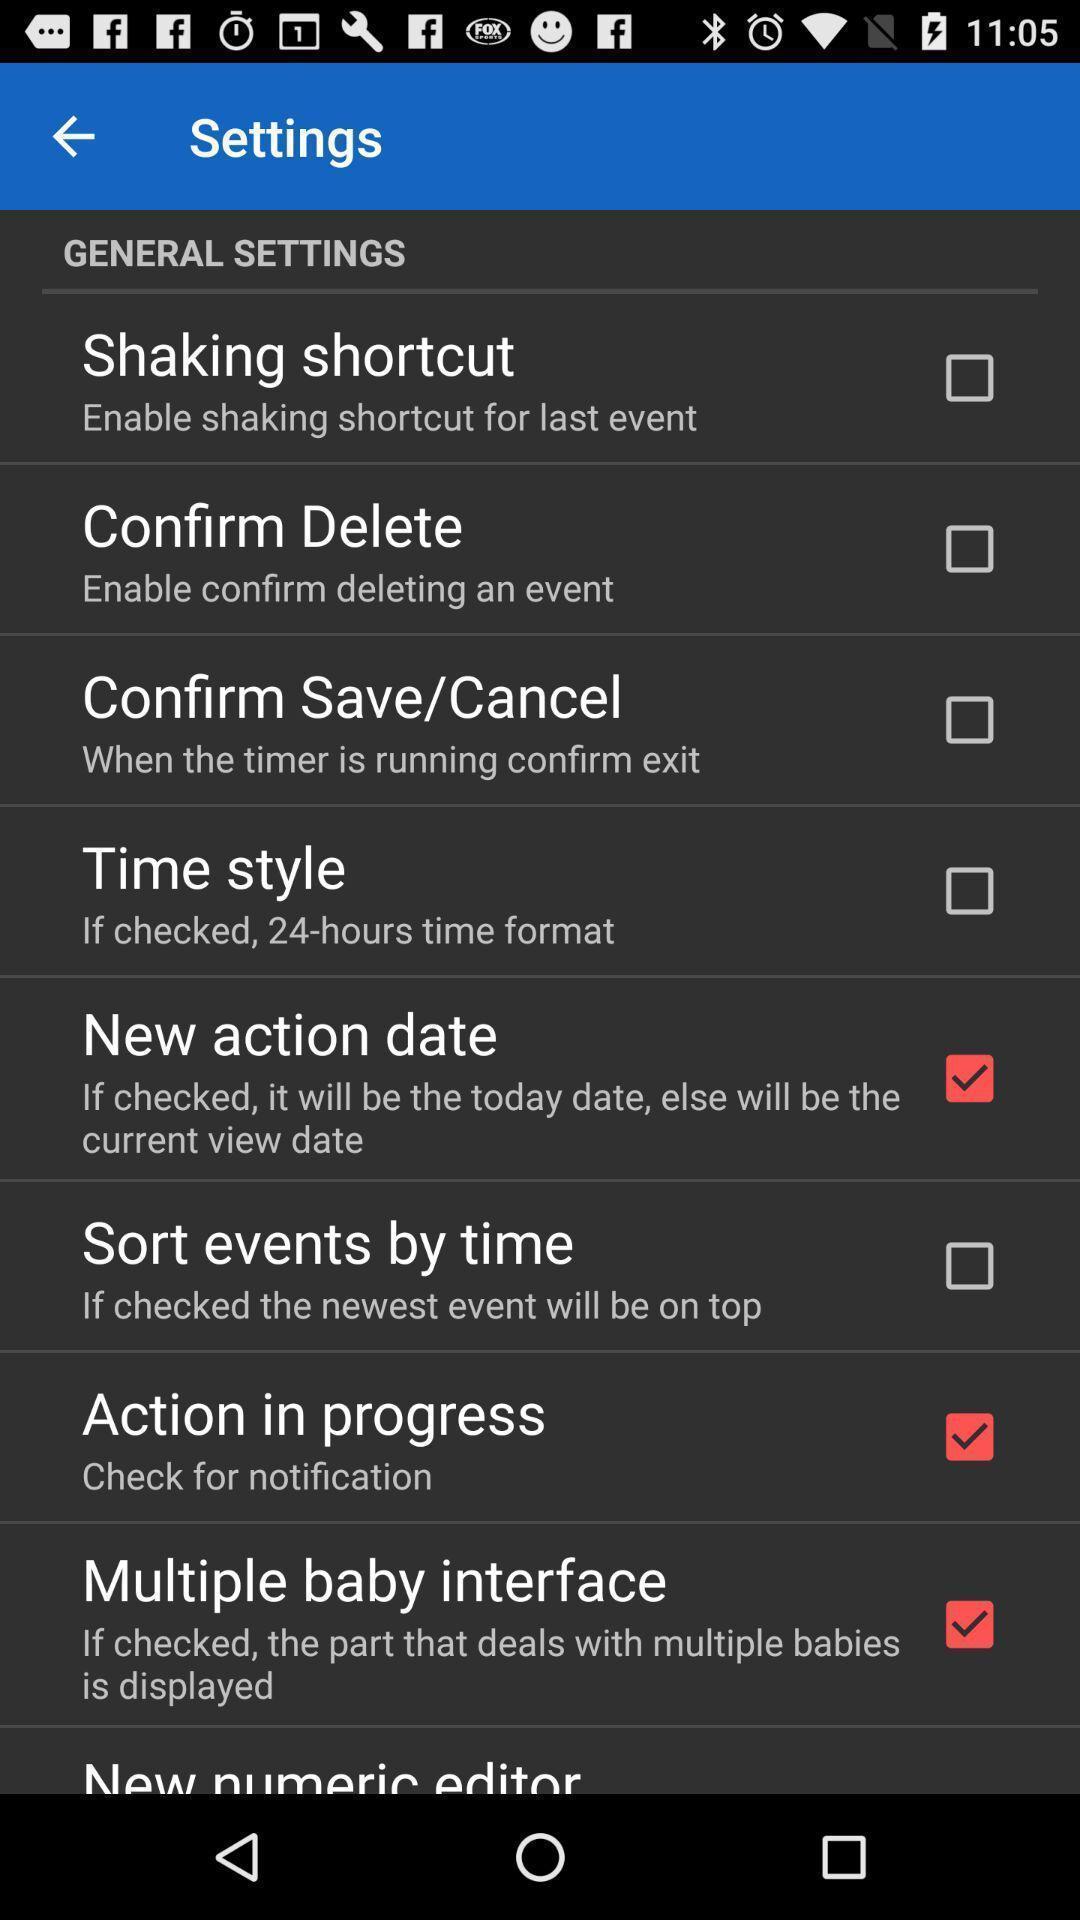Provide a textual representation of this image. Settings page displayed. 